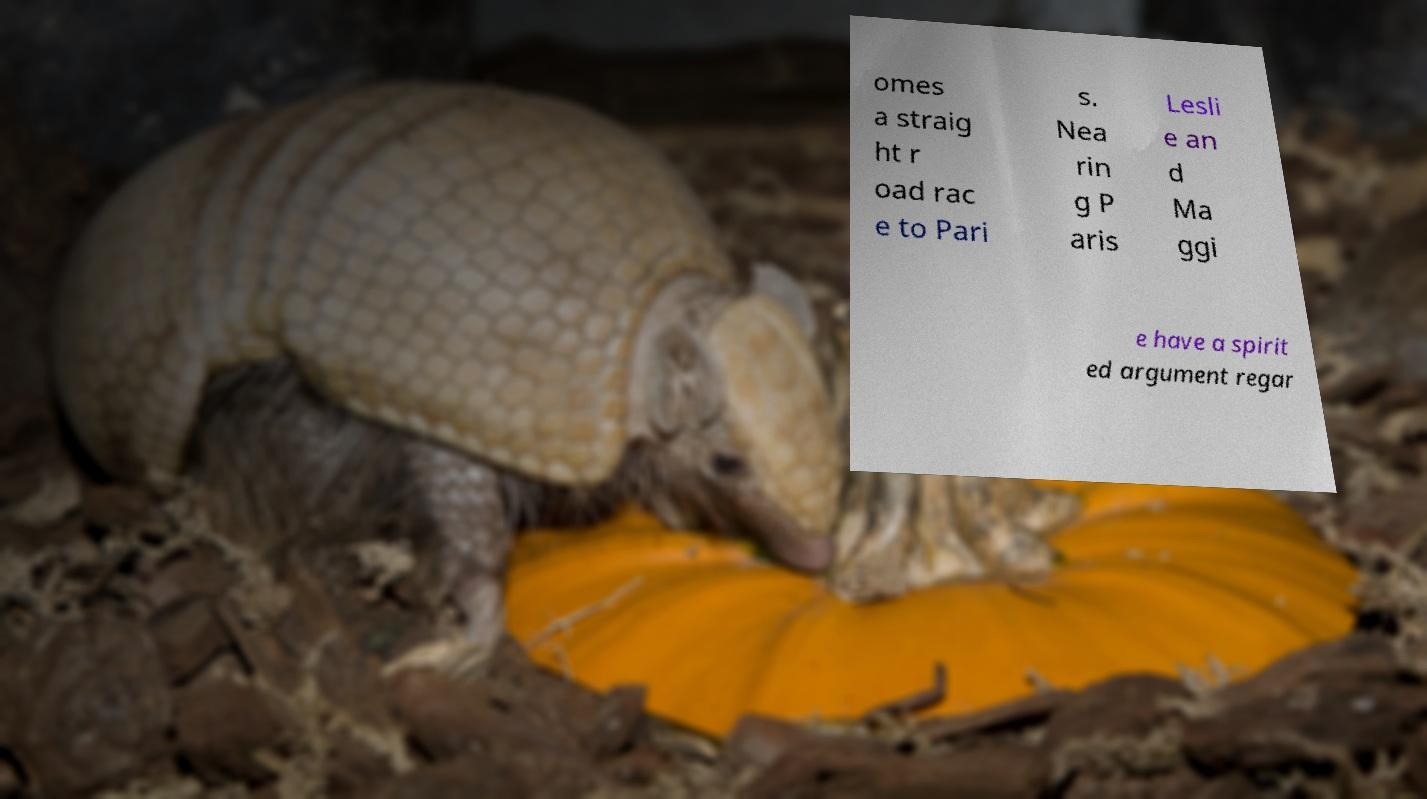Could you extract and type out the text from this image? omes a straig ht r oad rac e to Pari s. Nea rin g P aris Lesli e an d Ma ggi e have a spirit ed argument regar 